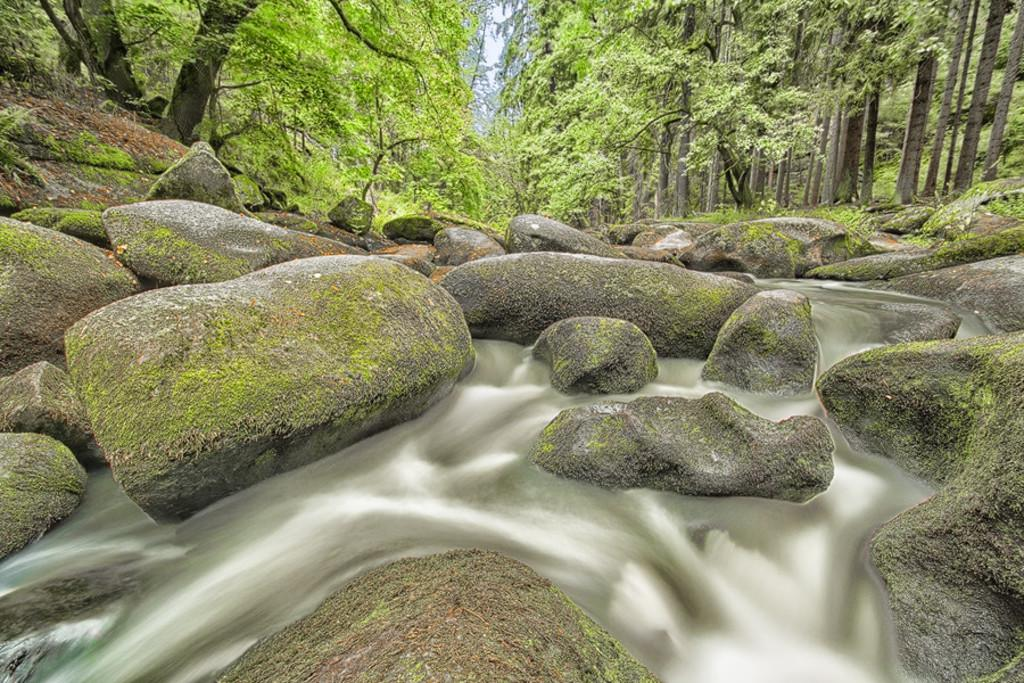What natural feature is the main subject of the image? There is a waterfall in the image. What can be seen on the ground near the waterfall? There are rocks on the ground in the image. What type of vegetation is visible in the background of the image? There are trees visible in the background of the image. Can you see an owl perched on one of the trees in the image? There is no owl present in the image; only the waterfall, rocks, and trees are visible. 